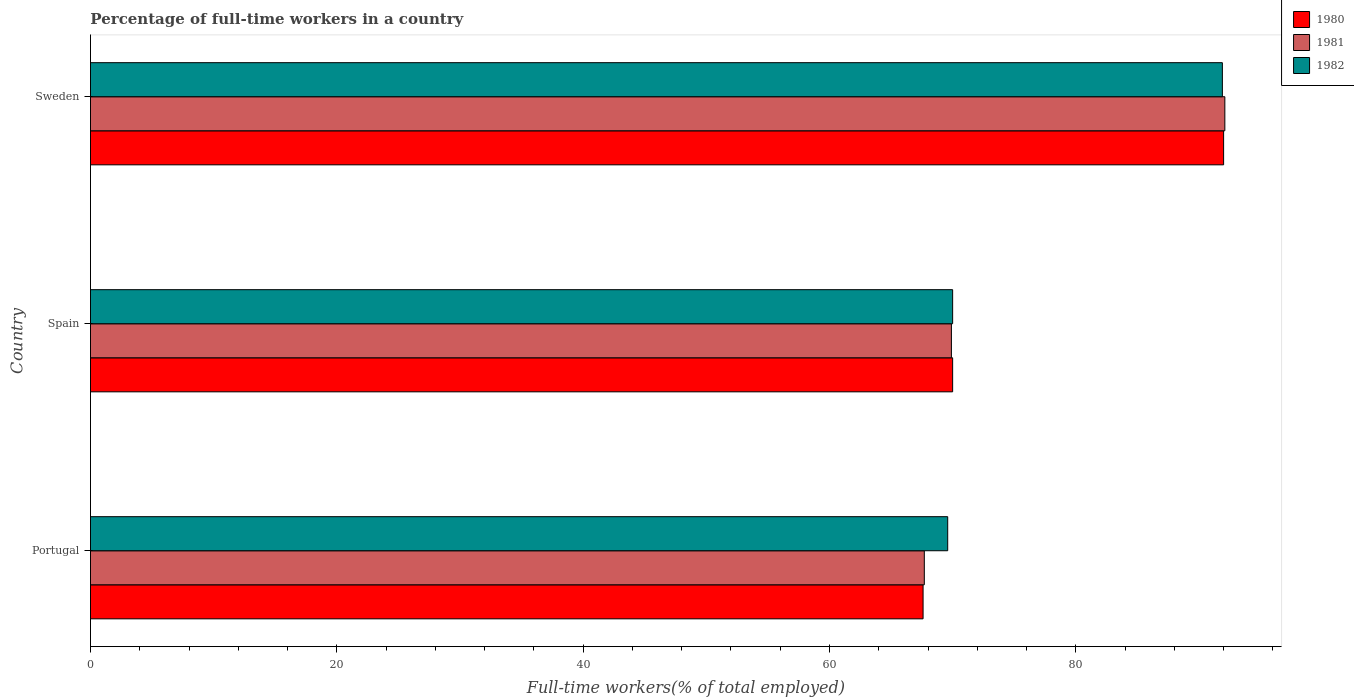How many groups of bars are there?
Your answer should be very brief. 3. Are the number of bars on each tick of the Y-axis equal?
Your answer should be very brief. Yes. How many bars are there on the 3rd tick from the top?
Your answer should be compact. 3. What is the percentage of full-time workers in 1981 in Portugal?
Your answer should be compact. 67.7. Across all countries, what is the maximum percentage of full-time workers in 1981?
Ensure brevity in your answer.  92.1. Across all countries, what is the minimum percentage of full-time workers in 1981?
Make the answer very short. 67.7. In which country was the percentage of full-time workers in 1981 minimum?
Make the answer very short. Portugal. What is the total percentage of full-time workers in 1982 in the graph?
Offer a terse response. 231.5. What is the difference between the percentage of full-time workers in 1981 in Spain and that in Sweden?
Offer a very short reply. -22.2. What is the difference between the percentage of full-time workers in 1982 in Portugal and the percentage of full-time workers in 1980 in Sweden?
Your answer should be very brief. -22.4. What is the average percentage of full-time workers in 1980 per country?
Your answer should be compact. 76.53. What is the difference between the percentage of full-time workers in 1980 and percentage of full-time workers in 1981 in Portugal?
Provide a short and direct response. -0.1. In how many countries, is the percentage of full-time workers in 1982 greater than 48 %?
Your answer should be very brief. 3. What is the ratio of the percentage of full-time workers in 1982 in Portugal to that in Sweden?
Your answer should be very brief. 0.76. Is the difference between the percentage of full-time workers in 1980 in Portugal and Spain greater than the difference between the percentage of full-time workers in 1981 in Portugal and Spain?
Keep it short and to the point. No. What is the difference between the highest and the second highest percentage of full-time workers in 1981?
Ensure brevity in your answer.  22.2. What is the difference between the highest and the lowest percentage of full-time workers in 1982?
Your response must be concise. 22.3. Are all the bars in the graph horizontal?
Ensure brevity in your answer.  Yes. Are the values on the major ticks of X-axis written in scientific E-notation?
Your answer should be compact. No. Does the graph contain any zero values?
Give a very brief answer. No. Does the graph contain grids?
Your answer should be very brief. No. How are the legend labels stacked?
Your answer should be very brief. Vertical. What is the title of the graph?
Your response must be concise. Percentage of full-time workers in a country. What is the label or title of the X-axis?
Offer a very short reply. Full-time workers(% of total employed). What is the Full-time workers(% of total employed) in 1980 in Portugal?
Provide a short and direct response. 67.6. What is the Full-time workers(% of total employed) in 1981 in Portugal?
Your answer should be very brief. 67.7. What is the Full-time workers(% of total employed) of 1982 in Portugal?
Ensure brevity in your answer.  69.6. What is the Full-time workers(% of total employed) in 1980 in Spain?
Provide a short and direct response. 70. What is the Full-time workers(% of total employed) in 1981 in Spain?
Offer a very short reply. 69.9. What is the Full-time workers(% of total employed) of 1980 in Sweden?
Give a very brief answer. 92. What is the Full-time workers(% of total employed) of 1981 in Sweden?
Give a very brief answer. 92.1. What is the Full-time workers(% of total employed) in 1982 in Sweden?
Make the answer very short. 91.9. Across all countries, what is the maximum Full-time workers(% of total employed) in 1980?
Provide a short and direct response. 92. Across all countries, what is the maximum Full-time workers(% of total employed) of 1981?
Give a very brief answer. 92.1. Across all countries, what is the maximum Full-time workers(% of total employed) in 1982?
Provide a succinct answer. 91.9. Across all countries, what is the minimum Full-time workers(% of total employed) in 1980?
Your response must be concise. 67.6. Across all countries, what is the minimum Full-time workers(% of total employed) of 1981?
Offer a terse response. 67.7. Across all countries, what is the minimum Full-time workers(% of total employed) in 1982?
Your answer should be compact. 69.6. What is the total Full-time workers(% of total employed) in 1980 in the graph?
Your response must be concise. 229.6. What is the total Full-time workers(% of total employed) of 1981 in the graph?
Offer a terse response. 229.7. What is the total Full-time workers(% of total employed) of 1982 in the graph?
Make the answer very short. 231.5. What is the difference between the Full-time workers(% of total employed) of 1980 in Portugal and that in Spain?
Your response must be concise. -2.4. What is the difference between the Full-time workers(% of total employed) of 1981 in Portugal and that in Spain?
Your response must be concise. -2.2. What is the difference between the Full-time workers(% of total employed) in 1982 in Portugal and that in Spain?
Provide a succinct answer. -0.4. What is the difference between the Full-time workers(% of total employed) of 1980 in Portugal and that in Sweden?
Offer a very short reply. -24.4. What is the difference between the Full-time workers(% of total employed) of 1981 in Portugal and that in Sweden?
Offer a terse response. -24.4. What is the difference between the Full-time workers(% of total employed) of 1982 in Portugal and that in Sweden?
Make the answer very short. -22.3. What is the difference between the Full-time workers(% of total employed) in 1980 in Spain and that in Sweden?
Provide a succinct answer. -22. What is the difference between the Full-time workers(% of total employed) of 1981 in Spain and that in Sweden?
Offer a terse response. -22.2. What is the difference between the Full-time workers(% of total employed) in 1982 in Spain and that in Sweden?
Keep it short and to the point. -21.9. What is the difference between the Full-time workers(% of total employed) of 1980 in Portugal and the Full-time workers(% of total employed) of 1981 in Sweden?
Your answer should be compact. -24.5. What is the difference between the Full-time workers(% of total employed) in 1980 in Portugal and the Full-time workers(% of total employed) in 1982 in Sweden?
Your answer should be very brief. -24.3. What is the difference between the Full-time workers(% of total employed) of 1981 in Portugal and the Full-time workers(% of total employed) of 1982 in Sweden?
Ensure brevity in your answer.  -24.2. What is the difference between the Full-time workers(% of total employed) of 1980 in Spain and the Full-time workers(% of total employed) of 1981 in Sweden?
Give a very brief answer. -22.1. What is the difference between the Full-time workers(% of total employed) of 1980 in Spain and the Full-time workers(% of total employed) of 1982 in Sweden?
Ensure brevity in your answer.  -21.9. What is the difference between the Full-time workers(% of total employed) in 1981 in Spain and the Full-time workers(% of total employed) in 1982 in Sweden?
Offer a terse response. -22. What is the average Full-time workers(% of total employed) of 1980 per country?
Provide a short and direct response. 76.53. What is the average Full-time workers(% of total employed) in 1981 per country?
Offer a terse response. 76.57. What is the average Full-time workers(% of total employed) in 1982 per country?
Your answer should be compact. 77.17. What is the difference between the Full-time workers(% of total employed) in 1981 and Full-time workers(% of total employed) in 1982 in Sweden?
Offer a very short reply. 0.2. What is the ratio of the Full-time workers(% of total employed) in 1980 in Portugal to that in Spain?
Provide a short and direct response. 0.97. What is the ratio of the Full-time workers(% of total employed) of 1981 in Portugal to that in Spain?
Ensure brevity in your answer.  0.97. What is the ratio of the Full-time workers(% of total employed) of 1980 in Portugal to that in Sweden?
Offer a terse response. 0.73. What is the ratio of the Full-time workers(% of total employed) in 1981 in Portugal to that in Sweden?
Provide a short and direct response. 0.74. What is the ratio of the Full-time workers(% of total employed) in 1982 in Portugal to that in Sweden?
Ensure brevity in your answer.  0.76. What is the ratio of the Full-time workers(% of total employed) of 1980 in Spain to that in Sweden?
Your answer should be compact. 0.76. What is the ratio of the Full-time workers(% of total employed) in 1981 in Spain to that in Sweden?
Offer a terse response. 0.76. What is the ratio of the Full-time workers(% of total employed) in 1982 in Spain to that in Sweden?
Provide a short and direct response. 0.76. What is the difference between the highest and the second highest Full-time workers(% of total employed) of 1980?
Your answer should be very brief. 22. What is the difference between the highest and the second highest Full-time workers(% of total employed) of 1982?
Give a very brief answer. 21.9. What is the difference between the highest and the lowest Full-time workers(% of total employed) in 1980?
Your response must be concise. 24.4. What is the difference between the highest and the lowest Full-time workers(% of total employed) of 1981?
Your answer should be very brief. 24.4. What is the difference between the highest and the lowest Full-time workers(% of total employed) of 1982?
Offer a terse response. 22.3. 